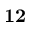<formula> <loc_0><loc_0><loc_500><loc_500>1 2</formula> 